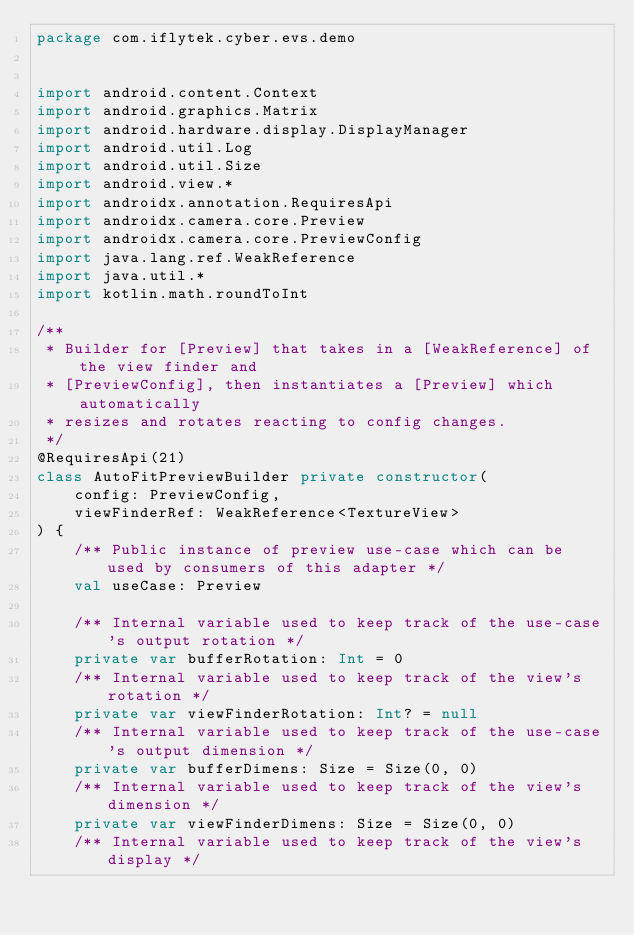Convert code to text. <code><loc_0><loc_0><loc_500><loc_500><_Kotlin_>package com.iflytek.cyber.evs.demo


import android.content.Context
import android.graphics.Matrix
import android.hardware.display.DisplayManager
import android.util.Log
import android.util.Size
import android.view.*
import androidx.annotation.RequiresApi
import androidx.camera.core.Preview
import androidx.camera.core.PreviewConfig
import java.lang.ref.WeakReference
import java.util.*
import kotlin.math.roundToInt

/**
 * Builder for [Preview] that takes in a [WeakReference] of the view finder and
 * [PreviewConfig], then instantiates a [Preview] which automatically
 * resizes and rotates reacting to config changes.
 */
@RequiresApi(21)
class AutoFitPreviewBuilder private constructor(
    config: PreviewConfig,
    viewFinderRef: WeakReference<TextureView>
) {
    /** Public instance of preview use-case which can be used by consumers of this adapter */
    val useCase: Preview

    /** Internal variable used to keep track of the use-case's output rotation */
    private var bufferRotation: Int = 0
    /** Internal variable used to keep track of the view's rotation */
    private var viewFinderRotation: Int? = null
    /** Internal variable used to keep track of the use-case's output dimension */
    private var bufferDimens: Size = Size(0, 0)
    /** Internal variable used to keep track of the view's dimension */
    private var viewFinderDimens: Size = Size(0, 0)
    /** Internal variable used to keep track of the view's display */</code> 